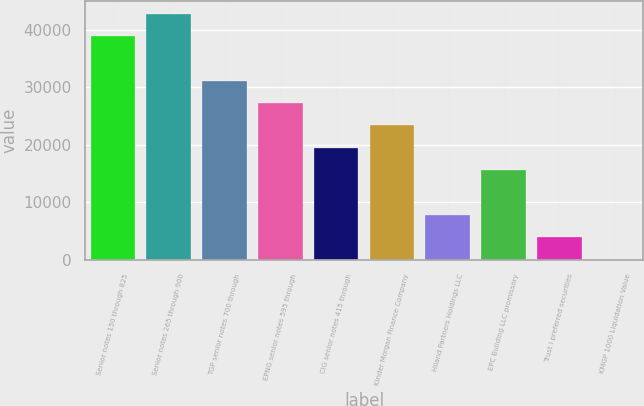Convert chart to OTSL. <chart><loc_0><loc_0><loc_500><loc_500><bar_chart><fcel>Senior notes 150 through 825<fcel>Senior notes 265 through 900<fcel>TGP senior notes 700 through<fcel>EPNG senior notes 595 through<fcel>CIG senior notes 415 through<fcel>Kinder Morgan Finance Company<fcel>Hiland Partners Holdings LLC<fcel>EPC Building LLC promissory<fcel>Trust I preferred securities<fcel>KMGP 1000 Liquidation Value<nl><fcel>38901<fcel>42781.1<fcel>31140.8<fcel>27260.7<fcel>19500.5<fcel>23380.6<fcel>7860.2<fcel>15620.4<fcel>3980.1<fcel>100<nl></chart> 